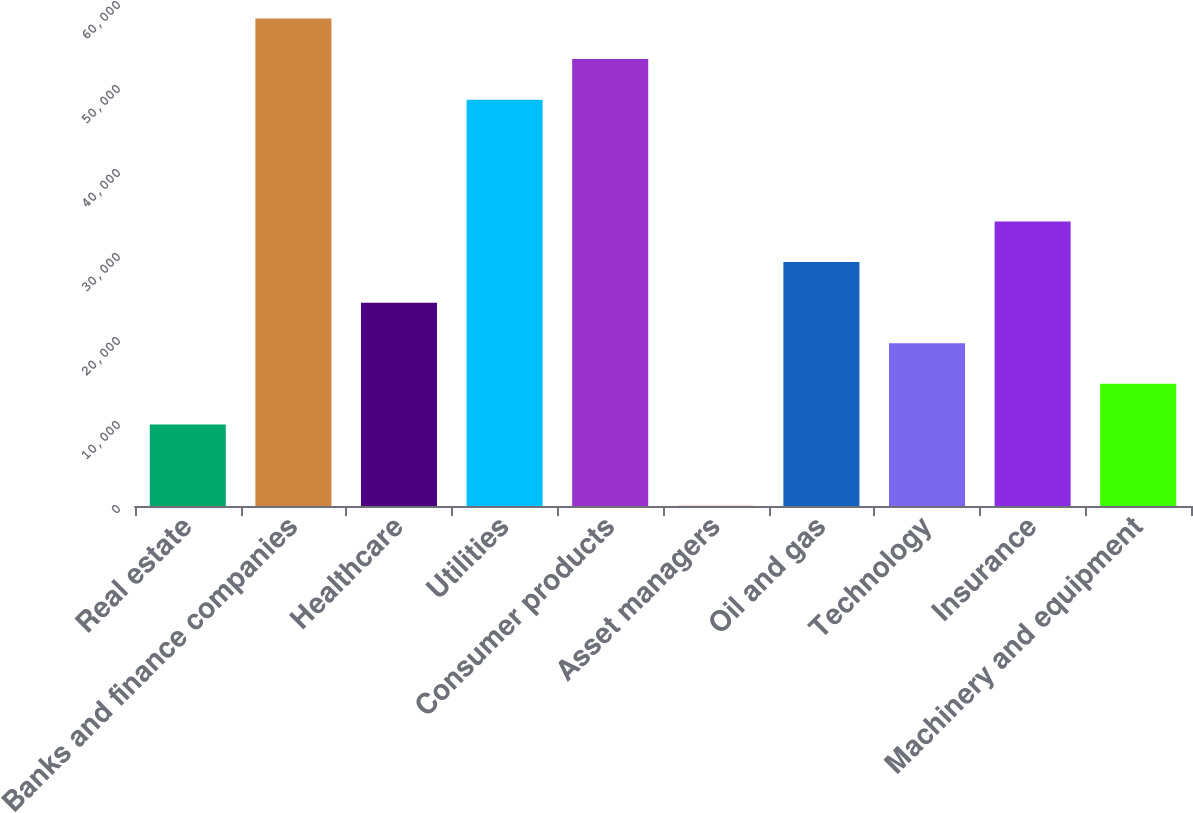Convert chart to OTSL. <chart><loc_0><loc_0><loc_500><loc_500><bar_chart><fcel>Real estate<fcel>Banks and finance companies<fcel>Healthcare<fcel>Utilities<fcel>Consumer products<fcel>Asset managers<fcel>Oil and gas<fcel>Technology<fcel>Insurance<fcel>Machinery and equipment<nl><fcel>9707.2<fcel>58043.2<fcel>24208<fcel>48376<fcel>53209.6<fcel>40<fcel>29041.6<fcel>19374.4<fcel>33875.2<fcel>14540.8<nl></chart> 